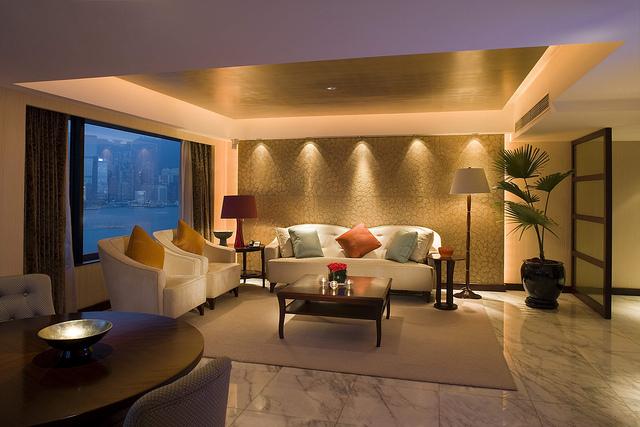Is this room disorganized?
Concise answer only. No. How many stains are on the carpet?
Be succinct. 0. Where is the house located?
Quick response, please. City. 